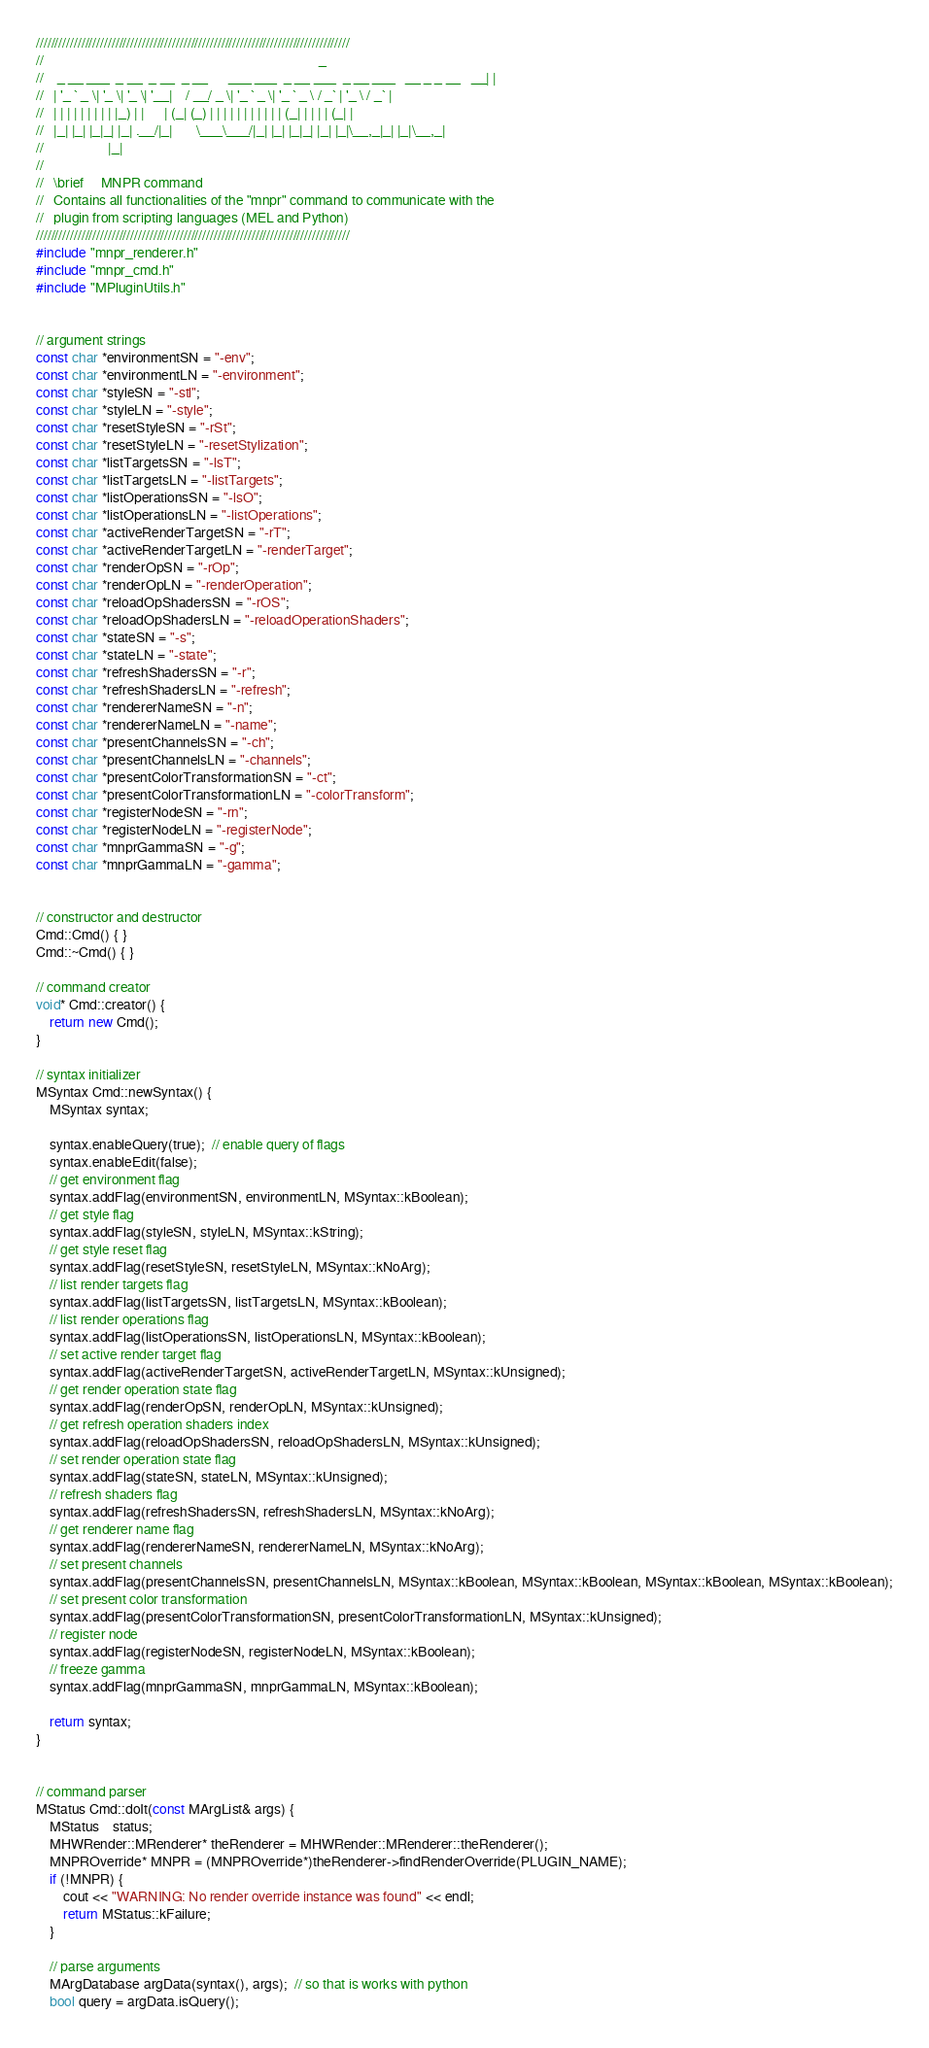Convert code to text. <code><loc_0><loc_0><loc_500><loc_500><_C++_>///////////////////////////////////////////////////////////////////////////////////
//                                                                                 _ 
//    _ __ ___  _ __  _ __  _ __      ___ ___  _ __ ___  _ __ ___   __ _ _ __   __| |
//   | '_ ` _ \| '_ \| '_ \| '__|    / __/ _ \| '_ ` _ \| '_ ` _ \ / _` | '_ \ / _` |
//   | | | | | | | | | |_) | |      | (_| (_) | | | | | | | | | | | (_| | | | | (_| |
//   |_| |_| |_|_| |_| .__/|_|       \___\___/|_| |_| |_|_| |_| |_|\__,_|_| |_|\__,_|
//                   |_|                                                             
//
//   \brief     MNPR command
//	 Contains all functionalities of the "mnpr" command to communicate with the
//   plugin from scripting languages (MEL and Python)
///////////////////////////////////////////////////////////////////////////////////
#include "mnpr_renderer.h"
#include "mnpr_cmd.h"
#include "MPluginUtils.h"


// argument strings
const char *environmentSN = "-env";
const char *environmentLN = "-environment";
const char *styleSN = "-stl";
const char *styleLN = "-style";
const char *resetStyleSN = "-rSt";
const char *resetStyleLN = "-resetStylization";
const char *listTargetsSN = "-lsT";
const char *listTargetsLN = "-listTargets";
const char *listOperationsSN = "-lsO";
const char *listOperationsLN = "-listOperations";
const char *activeRenderTargetSN = "-rT";
const char *activeRenderTargetLN = "-renderTarget";
const char *renderOpSN = "-rOp";
const char *renderOpLN = "-renderOperation";
const char *reloadOpShadersSN = "-rOS";
const char *reloadOpShadersLN = "-reloadOperationShaders";
const char *stateSN = "-s";
const char *stateLN = "-state";
const char *refreshShadersSN = "-r";
const char *refreshShadersLN = "-refresh";
const char *rendererNameSN = "-n";
const char *rendererNameLN = "-name";
const char *presentChannelsSN = "-ch";
const char *presentChannelsLN = "-channels";
const char *presentColorTransformationSN = "-ct";
const char *presentColorTransformationLN = "-colorTransform";
const char *registerNodeSN = "-rn";
const char *registerNodeLN = "-registerNode";
const char *mnprGammaSN = "-g";
const char *mnprGammaLN = "-gamma";


// constructor and destructor
Cmd::Cmd() { }
Cmd::~Cmd() { }

// command creator
void* Cmd::creator() {
    return new Cmd();
}

// syntax initializer
MSyntax Cmd::newSyntax() {
    MSyntax syntax;

    syntax.enableQuery(true);  // enable query of flags
    syntax.enableEdit(false);
    // get environment flag
    syntax.addFlag(environmentSN, environmentLN, MSyntax::kBoolean);
    // get style flag
    syntax.addFlag(styleSN, styleLN, MSyntax::kString);
    // get style reset flag
    syntax.addFlag(resetStyleSN, resetStyleLN, MSyntax::kNoArg);
    // list render targets flag
    syntax.addFlag(listTargetsSN, listTargetsLN, MSyntax::kBoolean);
    // list render operations flag
    syntax.addFlag(listOperationsSN, listOperationsLN, MSyntax::kBoolean);
    // set active render target flag
    syntax.addFlag(activeRenderTargetSN, activeRenderTargetLN, MSyntax::kUnsigned);
    // get render operation state flag
    syntax.addFlag(renderOpSN, renderOpLN, MSyntax::kUnsigned);
    // get refresh operation shaders index
    syntax.addFlag(reloadOpShadersSN, reloadOpShadersLN, MSyntax::kUnsigned);
    // set render operation state flag
    syntax.addFlag(stateSN, stateLN, MSyntax::kUnsigned);
    // refresh shaders flag
    syntax.addFlag(refreshShadersSN, refreshShadersLN, MSyntax::kNoArg);
    // get renderer name flag
    syntax.addFlag(rendererNameSN, rendererNameLN, MSyntax::kNoArg);
    // set present channels
    syntax.addFlag(presentChannelsSN, presentChannelsLN, MSyntax::kBoolean, MSyntax::kBoolean, MSyntax::kBoolean, MSyntax::kBoolean);
    // set present color transformation
    syntax.addFlag(presentColorTransformationSN, presentColorTransformationLN, MSyntax::kUnsigned);
    // register node
    syntax.addFlag(registerNodeSN, registerNodeLN, MSyntax::kBoolean);
    // freeze gamma
    syntax.addFlag(mnprGammaSN, mnprGammaLN, MSyntax::kBoolean);

    return syntax;
}


// command parser
MStatus Cmd::doIt(const MArgList& args) {
    MStatus	status;
    MHWRender::MRenderer* theRenderer = MHWRender::MRenderer::theRenderer();
    MNPROverride* MNPR = (MNPROverride*)theRenderer->findRenderOverride(PLUGIN_NAME);
    if (!MNPR) {
        cout << "WARNING: No render override instance was found" << endl;
        return MStatus::kFailure;
    }

    // parse arguments
    MArgDatabase argData(syntax(), args);  // so that is works with python
    bool query = argData.isQuery();
</code> 